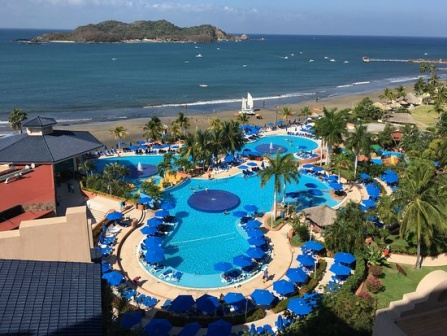What kind of water sports or activities might be popular at this resort, given its beachfront location? Given its prime beachfront location, this resort offers a variety of water sports and activities that promise excitement and adventure for guests of all ages. Popular activities likely include snorkeling, where guests can explore vibrant marine life in nearby reefs, and kayaking, offering a tranquil way to navigate the scenic coastline.

For thrill-seekers, jet skiing and parasailing are sure to be popular, providing exhilarating rides over the waves and stunning aerial views of the resort and its surroundings. Stand-up paddleboarding (SUP) offers a more relaxed pace and is a great way to enjoy the serene waters while engaging in a full-body workout.

The resort might also offer windsurfing and sailing activities, allowing guests to harness the coastal winds and experience the joy of skimming over the sparkling blue sea. For those interested in fishing, the resort could organize chartered fishing trips, enabling guests to try their hand at catching local fish species.

Additionally, the presence of boats suggests opportunities for scenic boat tours or even sunset cruises, allowing guests to bask in the breathtaking beauty of the coastal landscape as the sun sets over the horizon. These activities not only provide fun and adventure but also enable guests to fully immerse themselves in the natural beauty and splendor of the resort’s beachfront location. 